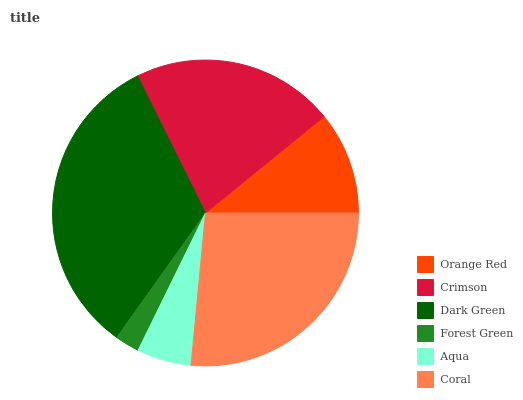Is Forest Green the minimum?
Answer yes or no. Yes. Is Dark Green the maximum?
Answer yes or no. Yes. Is Crimson the minimum?
Answer yes or no. No. Is Crimson the maximum?
Answer yes or no. No. Is Crimson greater than Orange Red?
Answer yes or no. Yes. Is Orange Red less than Crimson?
Answer yes or no. Yes. Is Orange Red greater than Crimson?
Answer yes or no. No. Is Crimson less than Orange Red?
Answer yes or no. No. Is Crimson the high median?
Answer yes or no. Yes. Is Orange Red the low median?
Answer yes or no. Yes. Is Orange Red the high median?
Answer yes or no. No. Is Coral the low median?
Answer yes or no. No. 